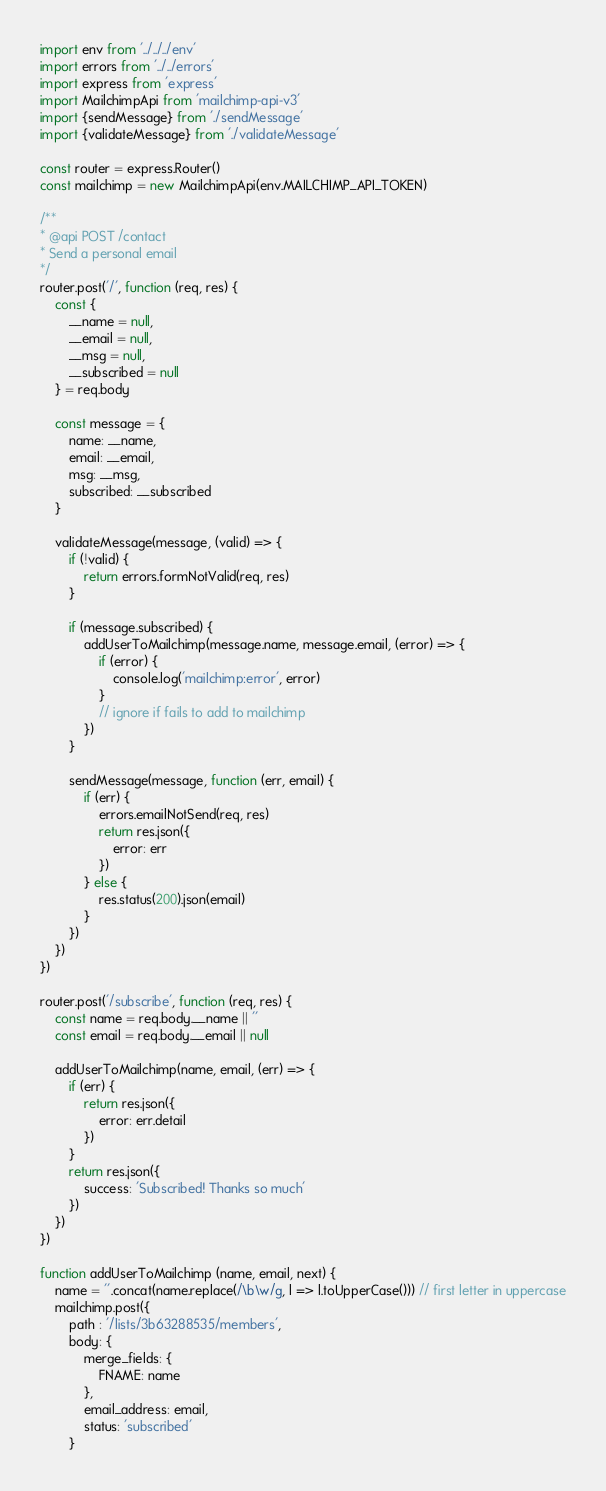Convert code to text. <code><loc_0><loc_0><loc_500><loc_500><_JavaScript_>import env from '../../../env'
import errors from '../../errors'
import express from 'express'
import MailchimpApi from 'mailchimp-api-v3'
import {sendMessage} from './sendMessage'
import {validateMessage} from './validateMessage'

const router = express.Router()
const mailchimp = new MailchimpApi(env.MAILCHIMP_API_TOKEN)

/**
* @api POST /contact
* Send a personal email
*/
router.post('/', function (req, res) {
    const {
        __name = null,
        __email = null,
        __msg = null,
        __subscribed = null
    } = req.body

    const message = {
        name: __name,
        email: __email,
        msg: __msg,
        subscribed: __subscribed
    }

    validateMessage(message, (valid) => {
        if (!valid) {
            return errors.formNotValid(req, res)
        }

        if (message.subscribed) {
            addUserToMailchimp(message.name, message.email, (error) => {
                if (error) {
                    console.log('mailchimp:error', error)
                }
                // ignore if fails to add to mailchimp
            })
        }

        sendMessage(message, function (err, email) {
            if (err) {
                errors.emailNotSend(req, res)
                return res.json({
                    error: err
                })
            } else {
                res.status(200).json(email)
            }
        })
    })
})

router.post('/subscribe', function (req, res) {
    const name = req.body.__name || ''
    const email = req.body.__email || null

    addUserToMailchimp(name, email, (err) => {
        if (err) {
            return res.json({
                error: err.detail
            })
        }
        return res.json({
            success: 'Subscribed! Thanks so much'
        })
    })
})

function addUserToMailchimp (name, email, next) {
    name = ''.concat(name.replace(/\b\w/g, l => l.toUpperCase())) // first letter in uppercase
    mailchimp.post({
        path : '/lists/3b63288535/members',
        body: {
            merge_fields: {
                FNAME: name
            },
            email_address: email,
            status: 'subscribed'
        }</code> 